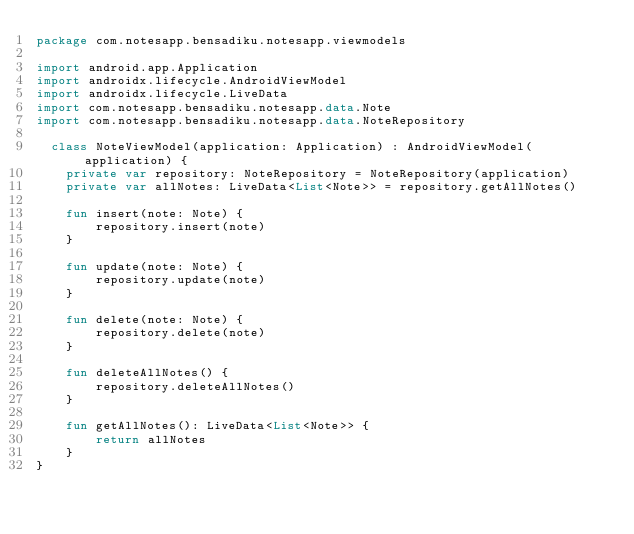<code> <loc_0><loc_0><loc_500><loc_500><_Kotlin_>package com.notesapp.bensadiku.notesapp.viewmodels

import android.app.Application
import androidx.lifecycle.AndroidViewModel
import androidx.lifecycle.LiveData
import com.notesapp.bensadiku.notesapp.data.Note
import com.notesapp.bensadiku.notesapp.data.NoteRepository

  class NoteViewModel(application: Application) : AndroidViewModel(application) {
    private var repository: NoteRepository = NoteRepository(application)
    private var allNotes: LiveData<List<Note>> = repository.getAllNotes()

    fun insert(note: Note) {
        repository.insert(note)
    }

    fun update(note: Note) {
        repository.update(note)
    }

    fun delete(note: Note) {
        repository.delete(note)
    }

    fun deleteAllNotes() {
        repository.deleteAllNotes()
    }

    fun getAllNotes(): LiveData<List<Note>> {
        return allNotes
    }
}</code> 